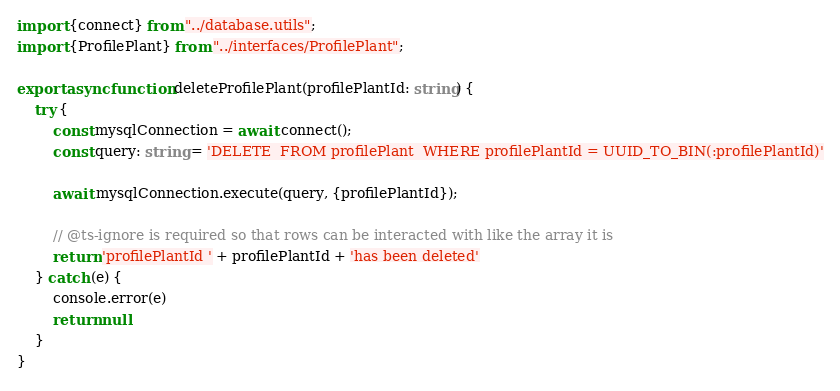<code> <loc_0><loc_0><loc_500><loc_500><_TypeScript_>import {connect} from "../database.utils";
import {ProfilePlant} from "../interfaces/ProfilePlant";

export async function deleteProfilePlant(profilePlantId: string) {
    try {
        const mysqlConnection = await connect();
        const query: string = 'DELETE  FROM profilePlant  WHERE profilePlantId = UUID_TO_BIN(:profilePlantId)'

        await mysqlConnection.execute(query, {profilePlantId});

        // @ts-ignore is required so that rows can be interacted with like the array it is
        return 'profilePlantId ' + profilePlantId + 'has been deleted'
    } catch (e) {
        console.error(e)
        return null
    }
}</code> 